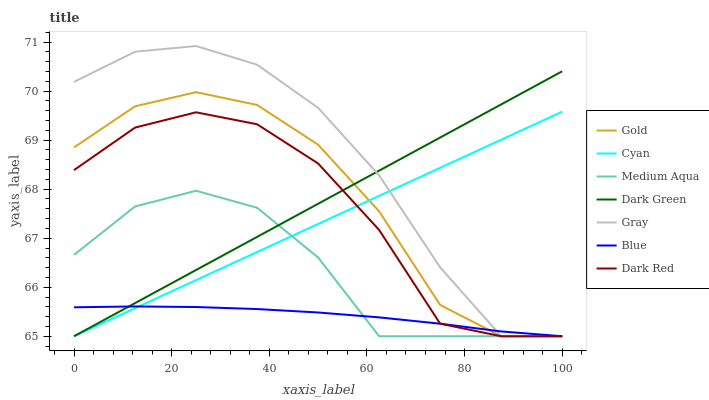Does Blue have the minimum area under the curve?
Answer yes or no. Yes. Does Gray have the maximum area under the curve?
Answer yes or no. Yes. Does Gold have the minimum area under the curve?
Answer yes or no. No. Does Gold have the maximum area under the curve?
Answer yes or no. No. Is Cyan the smoothest?
Answer yes or no. Yes. Is Dark Red the roughest?
Answer yes or no. Yes. Is Gray the smoothest?
Answer yes or no. No. Is Gray the roughest?
Answer yes or no. No. Does Blue have the lowest value?
Answer yes or no. Yes. Does Gray have the highest value?
Answer yes or no. Yes. Does Gold have the highest value?
Answer yes or no. No. Does Gray intersect Medium Aqua?
Answer yes or no. Yes. Is Gray less than Medium Aqua?
Answer yes or no. No. Is Gray greater than Medium Aqua?
Answer yes or no. No. 